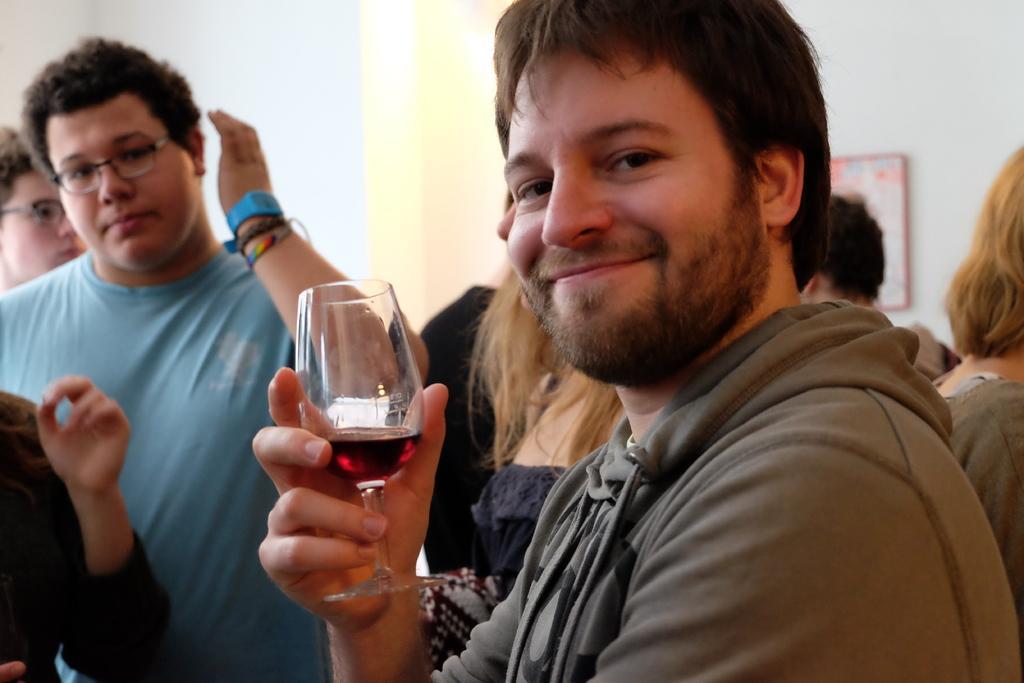Can you describe this image briefly? The person wearing grey dress is holding a glass of wine in his hand and there are some people behind him. 